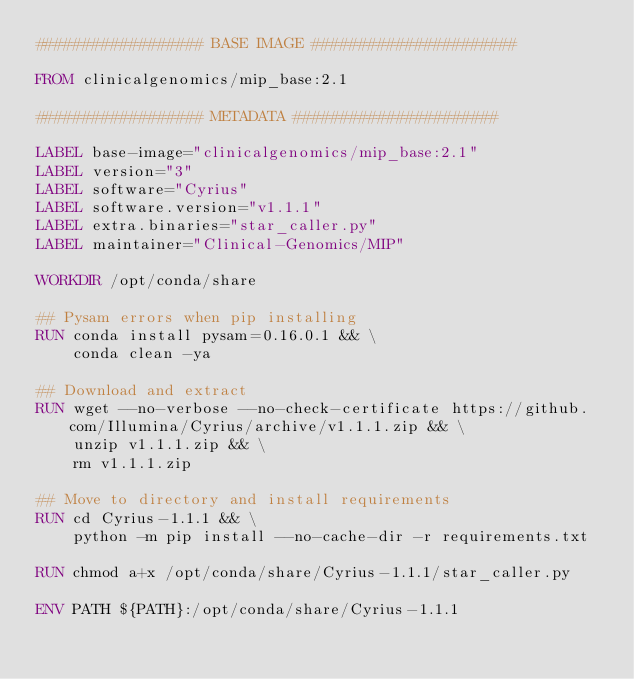<code> <loc_0><loc_0><loc_500><loc_500><_Dockerfile_>################## BASE IMAGE ######################

FROM clinicalgenomics/mip_base:2.1

################## METADATA ######################

LABEL base-image="clinicalgenomics/mip_base:2.1"
LABEL version="3"
LABEL software="Cyrius"
LABEL software.version="v1.1.1"
LABEL extra.binaries="star_caller.py"
LABEL maintainer="Clinical-Genomics/MIP"

WORKDIR /opt/conda/share

## Pysam errors when pip installing
RUN conda install pysam=0.16.0.1 && \
    conda clean -ya

## Download and extract
RUN wget --no-verbose --no-check-certificate https://github.com/Illumina/Cyrius/archive/v1.1.1.zip && \
    unzip v1.1.1.zip && \
    rm v1.1.1.zip

## Move to directory and install requirements
RUN cd Cyrius-1.1.1 && \
    python -m pip install --no-cache-dir -r requirements.txt

RUN chmod a+x /opt/conda/share/Cyrius-1.1.1/star_caller.py

ENV PATH ${PATH}:/opt/conda/share/Cyrius-1.1.1
</code> 